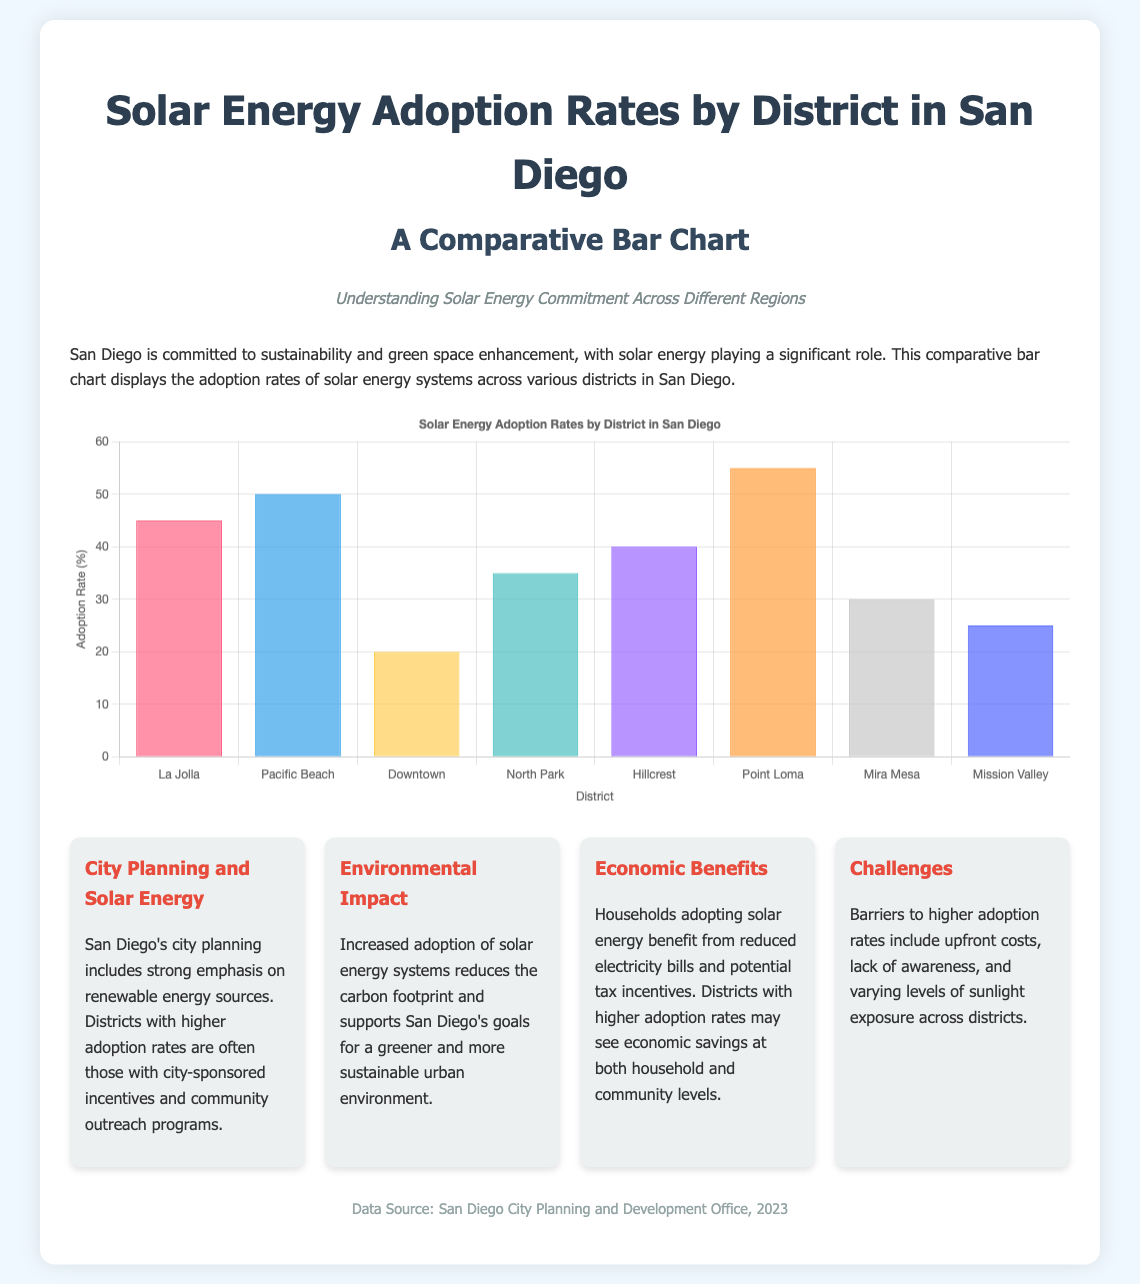What is the highest solar energy adoption rate? The highest adoption rate among the districts in the bar chart is found in Point Loma, which shows a rate of 55%.
Answer: 55% Which district has the lowest adoption rate? The bar chart indicates that Downtown has the lowest solar energy adoption rate at 20%.
Answer: Downtown How many districts are represented in the chart? The chart includes a total of eight districts where solar energy adoption rates are compared.
Answer: Eight What is the adoption rate of La Jolla? According to the data in the chart, La Jolla has an adoption rate of 45%.
Answer: 45% What key benefit is highlighted for households adopting solar energy? The information card states that households benefit from reduced electricity bills when they adopt solar energy.
Answer: Reduced electricity bills Which districts are noted as having community outreach programs? The information suggests that districts with higher adoption rates often have city-sponsored incentives and community outreach programs, specifically mentioned in relation to district performance.
Answer: Not specified Why is increased solar energy adoption important for San Diego? The document mentions that increased adoption reduces the carbon footprint and supports San Diego's greener urban environment goals.
Answer: Reduces carbon footprint What is the data source for this infographic? The footnote at the bottom of the document specifies that the data source is the San Diego City Planning and Development Office, 2023.
Answer: San Diego City Planning and Development Office, 2023 